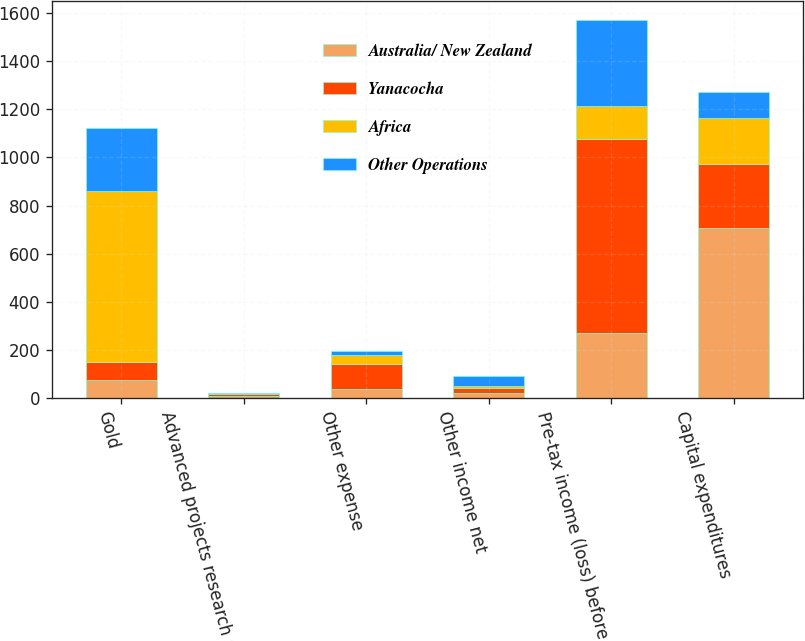Convert chart to OTSL. <chart><loc_0><loc_0><loc_500><loc_500><stacked_bar_chart><ecel><fcel>Gold<fcel>Advanced projects research and<fcel>Other expense<fcel>Other income net<fcel>Pre-tax income (loss) before<fcel>Capital expenditures<nl><fcel>Australia/ New Zealand<fcel>75<fcel>10<fcel>36<fcel>22<fcel>270<fcel>705<nl><fcel>Yanacocha<fcel>75<fcel>6<fcel>105<fcel>19<fcel>808<fcel>269<nl><fcel>Africa<fcel>709<fcel>2<fcel>36<fcel>7<fcel>135<fcel>192<nl><fcel>Other Operations<fcel>264<fcel>2<fcel>18<fcel>45<fcel>357<fcel>106<nl></chart> 